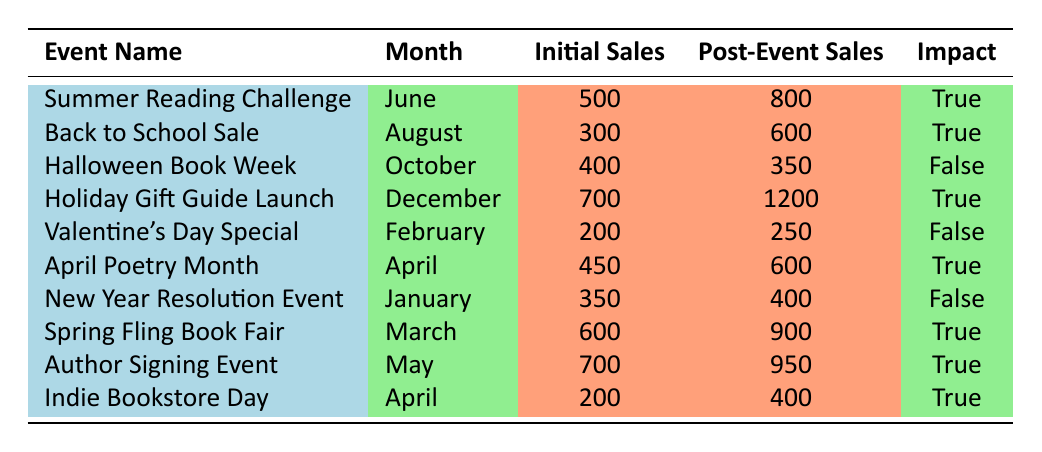What is the total number of promotional events that had a positive impact on sales? By examining the "Impact" column in the table, we find that 6 events are marked as true. These events are: Summer Reading Challenge, Back to School Sale, Holiday Gift Guide Launch, April Poetry Month, Spring Fling Book Fair, and Author Signing Event.
Answer: 6 Which promotional event had the highest initial sales? Reviewing the "Initial Sales" column, the event with the highest initial sales is the Author Signing Event with 700 sales.
Answer: Author Signing Event Did the Halloween Book Week have an impact on book sales? The "Impact" column clearly states that the Halloween Book Week had a false designation for impact, indicating it did not positively affect sales.
Answer: No What is the difference in sales for the Summer Reading Challenge before and after the event? We calculate this by taking the post-event sales of 800 and subtracting the initial sales of 500. The difference is 800 - 500 = 300.
Answer: 300 Which month had the most promotional events with a positive impact recorded? Upon reviewing the table, April has two events with a positive impact: April Poetry Month and Indie Bookstore Day. Therefore, the month with the most positive impact events is April.
Answer: April What is the average increase in sales for all events with a positive impact? To find the average increase, we first look at all events with a positive impact: Summer Reading Challenge (300), Back to School Sale (300), Holiday Gift Guide Launch (500), April Poetry Month (150), Spring Fling Book Fair (300), and Author Signing Event (250). The total increase is 300 + 300 + 500 + 150 + 300 + 250 = 1800. Dividing by the 6 events gives an average increase of 1800/6 = 300.
Answer: 300 How many events were held in the month of April? The table shows that there are two events in the month of April: April Poetry Month and Indie Bookstore Day.
Answer: 2 What percentage of the total events had a negative impact on sales? There are 10 total events and 4 of them are categorized with a negative impact. To find the percentage: (4 negative events / 10 total events) * 100 = 40%.
Answer: 40% 